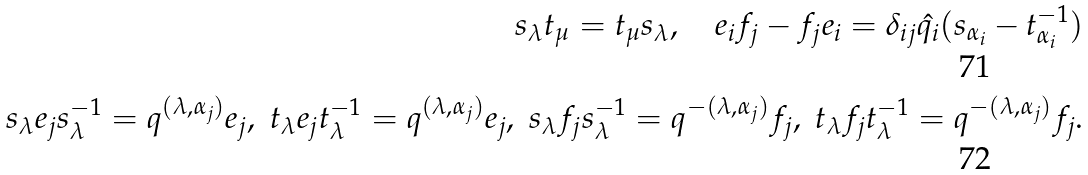Convert formula to latex. <formula><loc_0><loc_0><loc_500><loc_500>s _ { \lambda } t _ { \mu } = t _ { \mu } s _ { \lambda } , \quad e _ { i } f _ { j } - f _ { j } e _ { i } = \delta _ { i j } \hat { q _ { i } } ( s _ { \alpha _ { i } } - t _ { \alpha _ { i } } ^ { - 1 } ) \\ s _ { \lambda } e _ { j } s _ { \lambda } ^ { - 1 } = q ^ { ( \lambda , \alpha _ { j } ) } e _ { j } , \ t _ { \lambda } e _ { j } t _ { \lambda } ^ { - 1 } = q ^ { ( \lambda , \alpha _ { j } ) } e _ { j } , \ s _ { \lambda } f _ { j } s _ { \lambda } ^ { - 1 } = q ^ { - ( \lambda , \alpha _ { j } ) } f _ { j } , \ t _ { \lambda } f _ { j } t _ { \lambda } ^ { - 1 } = q ^ { - ( \lambda , \alpha _ { j } ) } f _ { j } .</formula> 